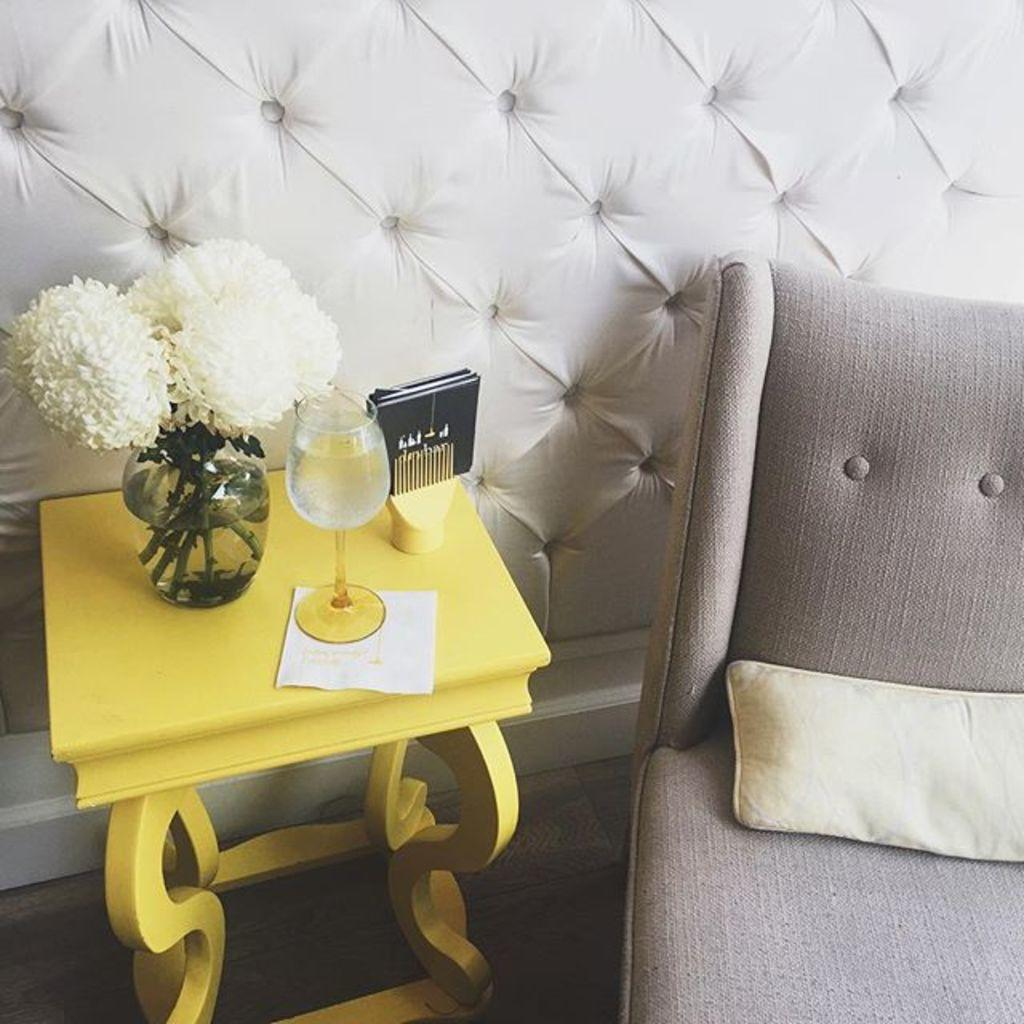What piece of furniture is present in the image? There is a table in the image. What objects can be seen on the table? There is a glass, a paper, a flower, and a flower pot on the table. What is the floor like in the image? The floor is visible in the image. What type of seating is available in the image? There is a chair in the image. What is placed on the chair? There is a pillow on the chair. Can you tell me how many seeds are in the flower on the table? There is no information about the number of seeds in the flower on the table, as the focus is on the presence of the flower and not its internal structure. 